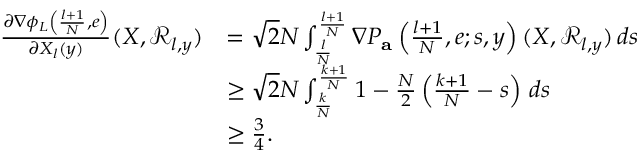Convert formula to latex. <formula><loc_0><loc_0><loc_500><loc_500>\begin{array} { r l } { \frac { \partial \nabla \phi _ { L } \left ( \frac { l + 1 } { N } , e \right ) } { \partial X _ { l } ( y ) } ( X , \mathcal { R } _ { l , y } ) } & { = \sqrt { 2 } N \int _ { \frac { l } { N } } ^ { \frac { l + 1 } { N } } \nabla P _ { a } \left ( \frac { l + 1 } { N } , e ; s , y \right ) ( X , \mathcal { R } _ { l , y } ) \, d s } \\ & { \geq \sqrt { 2 } N \int _ { \frac { k } { N } } ^ { \frac { k + 1 } { N } } 1 - \frac { N } { 2 } \left ( \frac { k + 1 } { N } - s \right ) \, d s } \\ & { \geq \frac { 3 } { 4 } . } \end{array}</formula> 